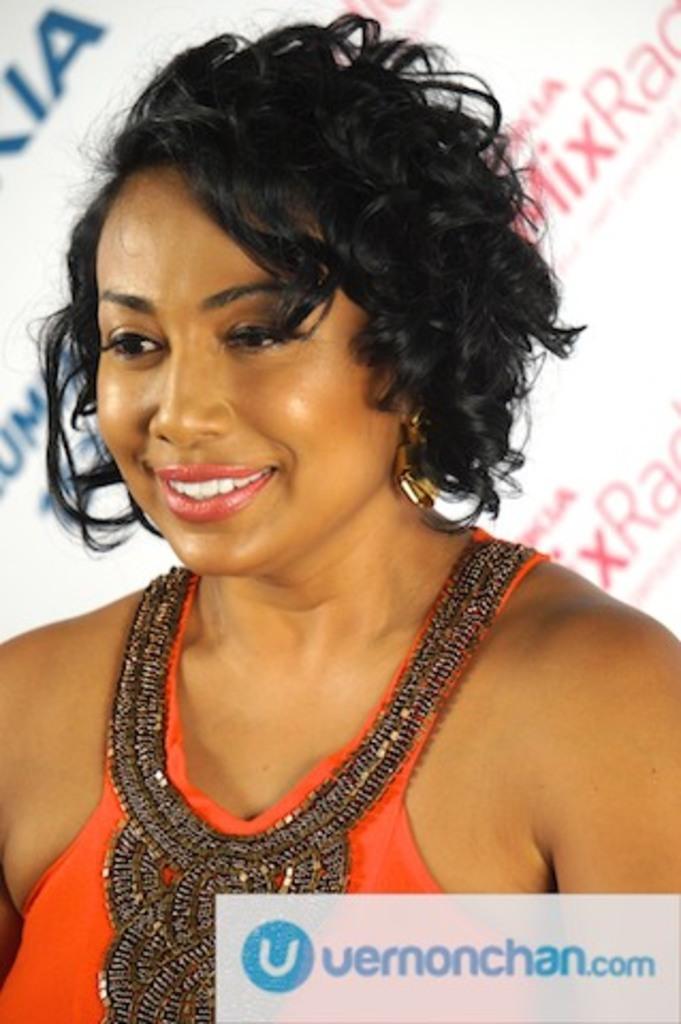Can you describe this image briefly? In this image we can see a person wearing orange color dress. 